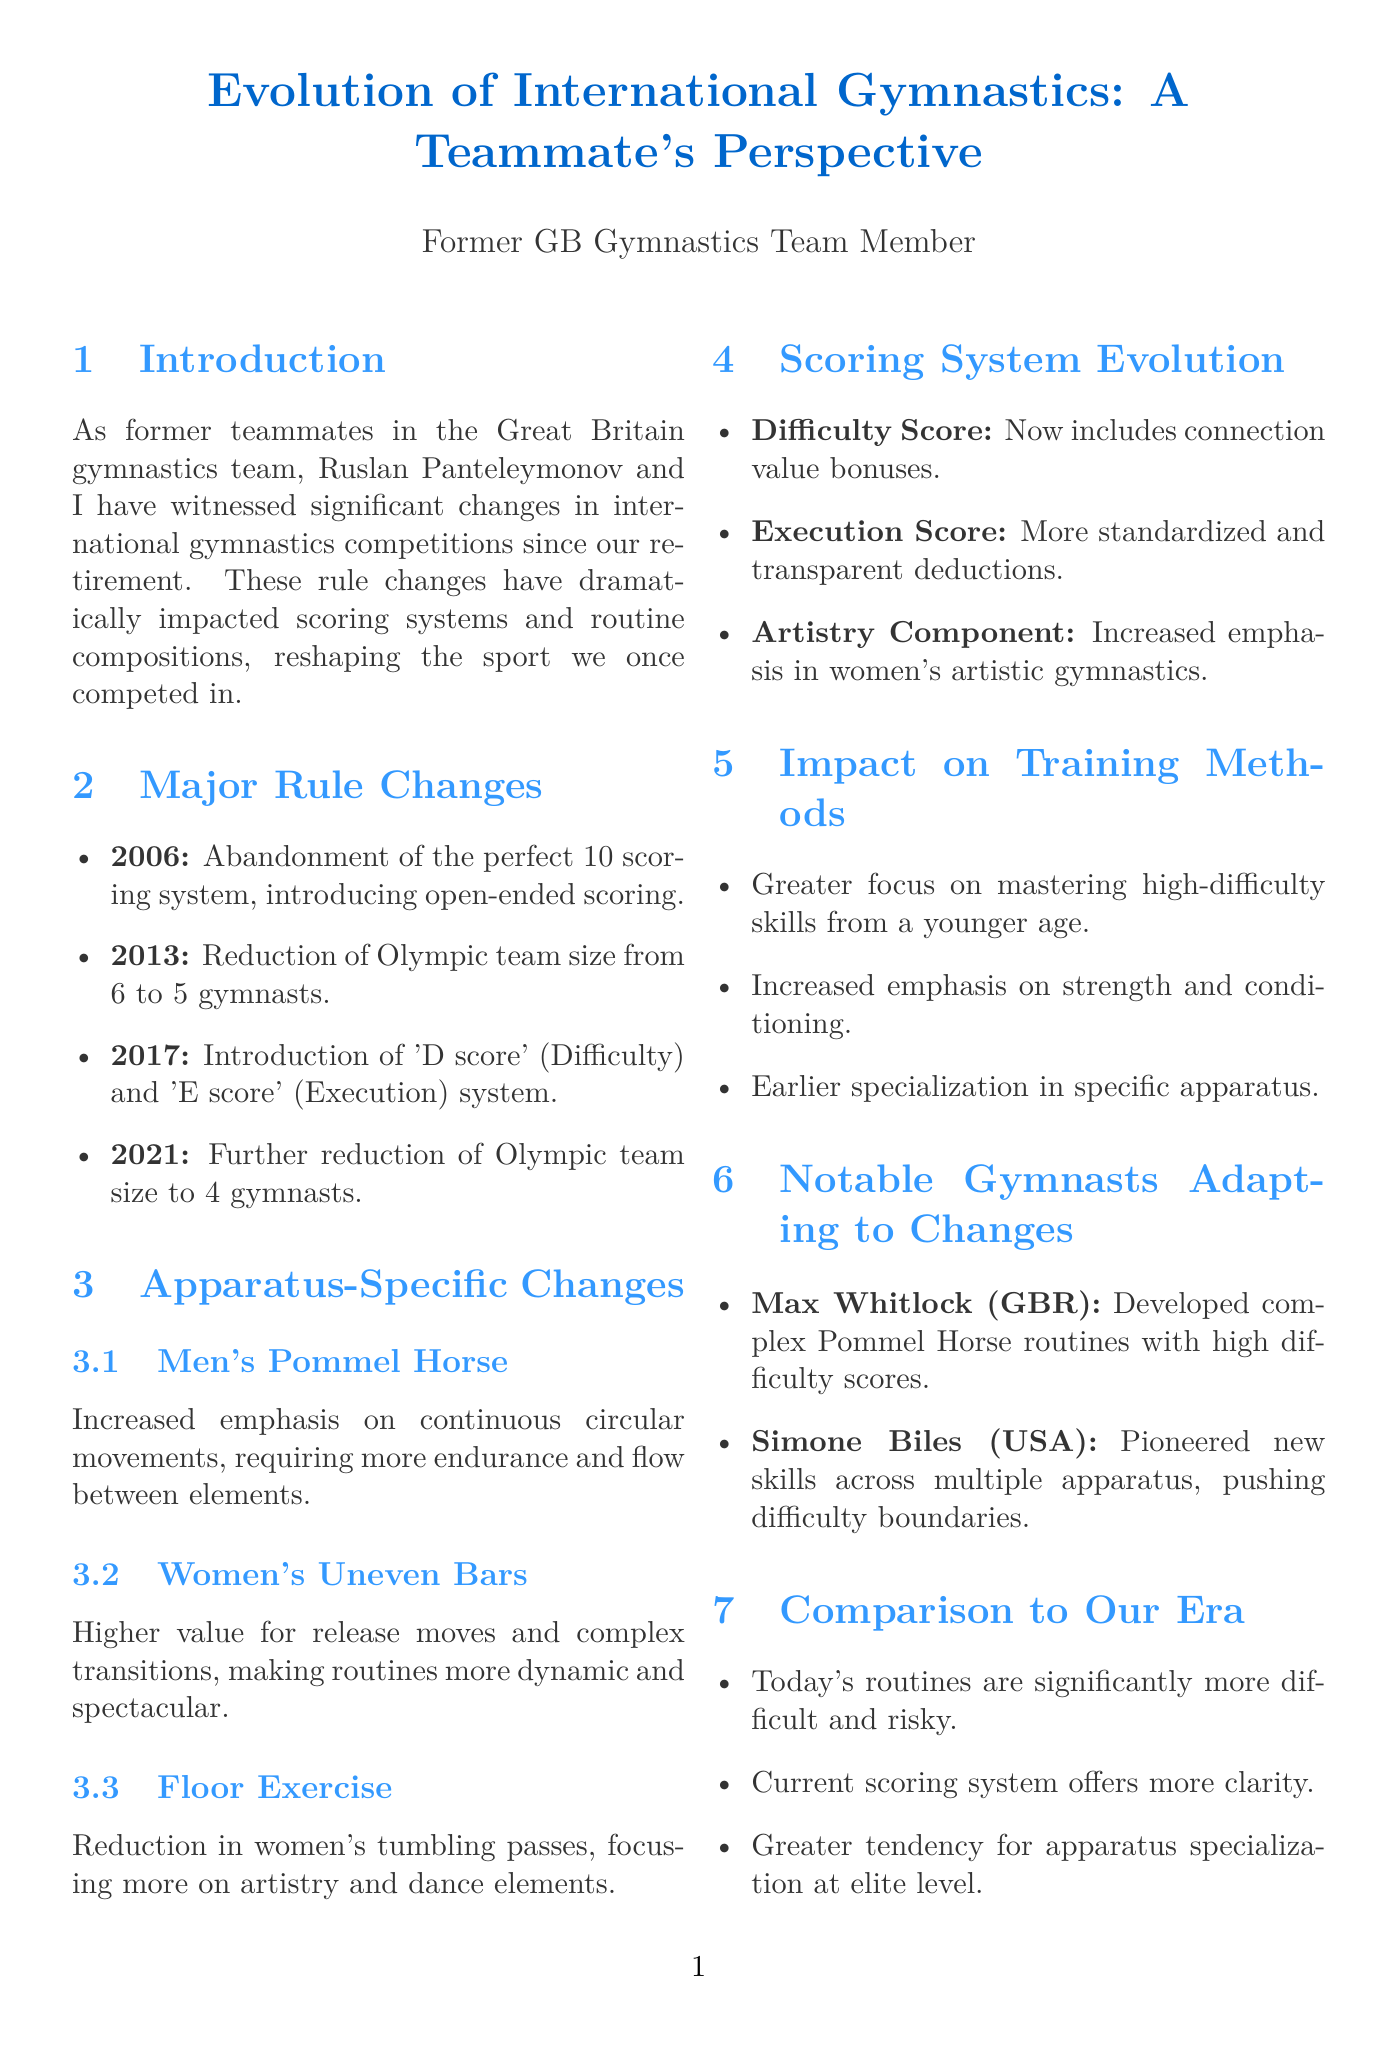what was abandoned in 2006? The document states that the perfect 10 scoring system was abandoned in 2006.
Answer: perfect 10 scoring system what change occurred in 2013 regarding team size? In 2013, the Olympic team size was reduced from 6 to 5 gymnasts.
Answer: reduced from 6 to 5 gymnasts how many gymnasts are now in an Olympic team as of 2021? According to the document, the Olympic team size was further reduced to 4 gymnasts in 2021.
Answer: 4 gymnasts which gymnast is noted for developing complex routines on the pommel horse? The document identifies Max Whitlock as the gymnast known for complex routines on the pommel horse.
Answer: Max Whitlock what emphasis has increased in women’s artistic gymnastics? The document notes an increased emphasis on the artistry component in women's artistic gymnastics.
Answer: artistry component how have today's routines compared to those during our era? The document states that today's routines are significantly more difficult and risky compared to those during our competitive years.
Answer: significantly more difficult and risky what is one potential future consideration mentioned in the document? Possible reintroduction of capped scoring is one of the future considerations highlighted in the report.
Answer: reintroduction of capped scoring which system was introduced in 2017? The document mentions the introduction of the 'D score' (Difficulty) and 'E score' (Execution) system in 2017.
Answer: 'D score' and 'E score' system what does the increased focus on training methods emphasize? The document states that training methods now emphasize mastering high-difficulty skills from a younger age.
Answer: mastering high-difficulty skills from a younger age 